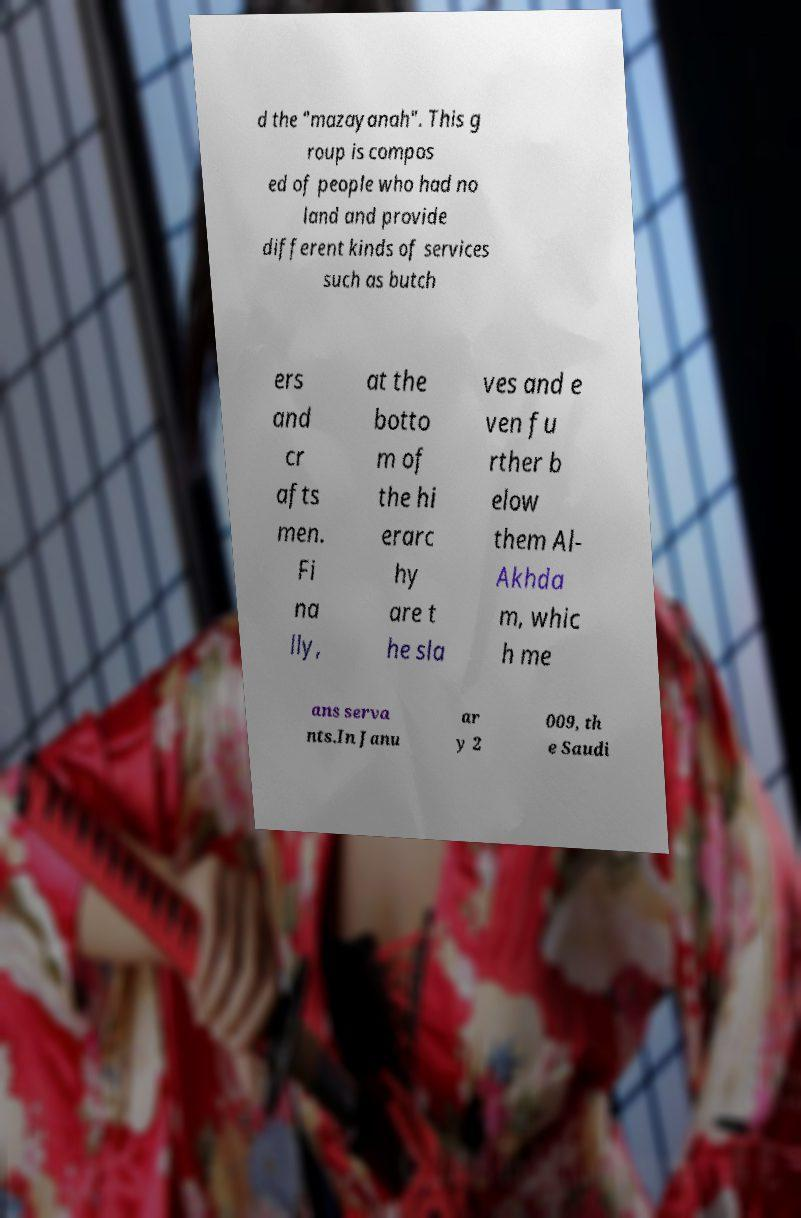There's text embedded in this image that I need extracted. Can you transcribe it verbatim? d the "mazayanah". This g roup is compos ed of people who had no land and provide different kinds of services such as butch ers and cr afts men. Fi na lly, at the botto m of the hi erarc hy are t he sla ves and e ven fu rther b elow them Al- Akhda m, whic h me ans serva nts.In Janu ar y 2 009, th e Saudi 